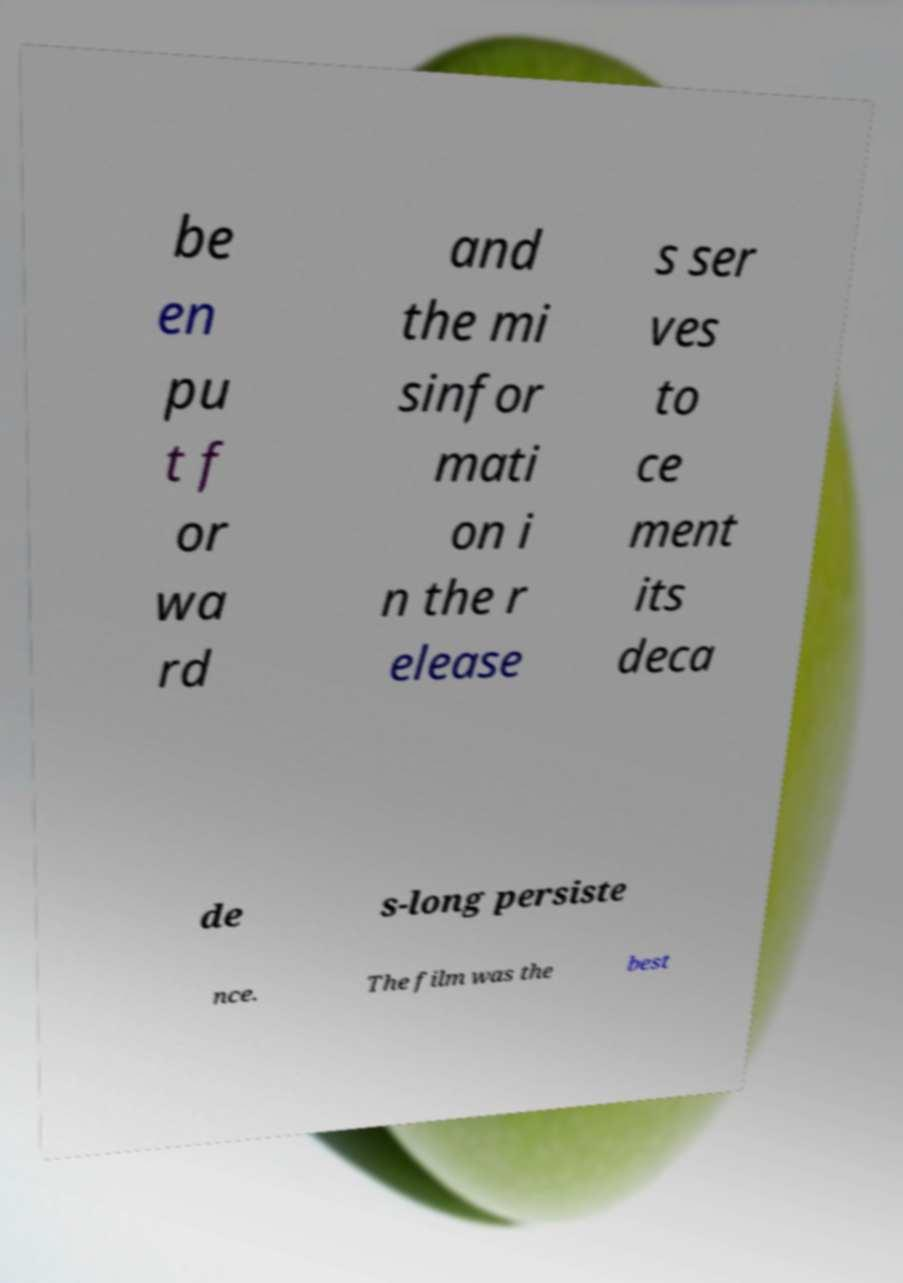Please identify and transcribe the text found in this image. be en pu t f or wa rd and the mi sinfor mati on i n the r elease s ser ves to ce ment its deca de s-long persiste nce. The film was the best 